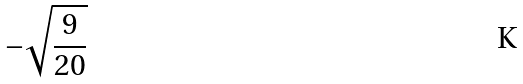Convert formula to latex. <formula><loc_0><loc_0><loc_500><loc_500>- \sqrt { \frac { 9 } { 2 0 } }</formula> 